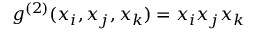Convert formula to latex. <formula><loc_0><loc_0><loc_500><loc_500>{ g } ^ { ( 2 ) } ( x _ { i } , x _ { j } , x _ { k } ) = x _ { i } x _ { j } x _ { k }</formula> 